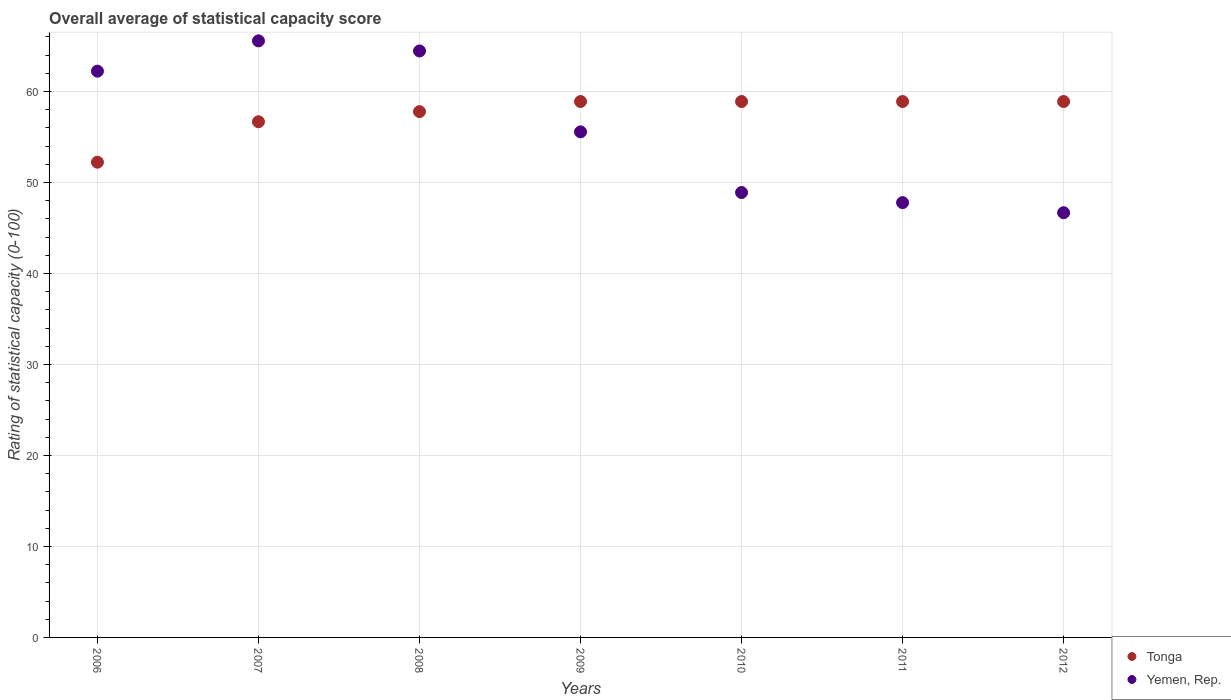Is the number of dotlines equal to the number of legend labels?
Make the answer very short. Yes. What is the rating of statistical capacity in Yemen, Rep. in 2010?
Ensure brevity in your answer.  48.89. Across all years, what is the maximum rating of statistical capacity in Yemen, Rep.?
Your answer should be compact. 65.56. Across all years, what is the minimum rating of statistical capacity in Tonga?
Your answer should be compact. 52.22. In which year was the rating of statistical capacity in Tonga maximum?
Make the answer very short. 2009. In which year was the rating of statistical capacity in Tonga minimum?
Your answer should be compact. 2006. What is the total rating of statistical capacity in Tonga in the graph?
Your answer should be compact. 402.22. What is the difference between the rating of statistical capacity in Tonga in 2006 and that in 2011?
Keep it short and to the point. -6.67. What is the difference between the rating of statistical capacity in Yemen, Rep. in 2007 and the rating of statistical capacity in Tonga in 2008?
Your answer should be compact. 7.78. What is the average rating of statistical capacity in Tonga per year?
Provide a succinct answer. 57.46. In the year 2011, what is the difference between the rating of statistical capacity in Tonga and rating of statistical capacity in Yemen, Rep.?
Make the answer very short. 11.11. In how many years, is the rating of statistical capacity in Yemen, Rep. greater than 24?
Offer a terse response. 7. What is the ratio of the rating of statistical capacity in Yemen, Rep. in 2009 to that in 2011?
Keep it short and to the point. 1.16. Is the rating of statistical capacity in Tonga in 2010 less than that in 2012?
Keep it short and to the point. No. What is the difference between the highest and the second highest rating of statistical capacity in Yemen, Rep.?
Make the answer very short. 1.11. What is the difference between the highest and the lowest rating of statistical capacity in Tonga?
Ensure brevity in your answer.  6.67. In how many years, is the rating of statistical capacity in Yemen, Rep. greater than the average rating of statistical capacity in Yemen, Rep. taken over all years?
Your response must be concise. 3. Is the sum of the rating of statistical capacity in Tonga in 2008 and 2012 greater than the maximum rating of statistical capacity in Yemen, Rep. across all years?
Give a very brief answer. Yes. Does the rating of statistical capacity in Yemen, Rep. monotonically increase over the years?
Make the answer very short. No. How many dotlines are there?
Make the answer very short. 2. Does the graph contain grids?
Offer a terse response. Yes. Where does the legend appear in the graph?
Provide a short and direct response. Bottom right. What is the title of the graph?
Offer a terse response. Overall average of statistical capacity score. Does "Ethiopia" appear as one of the legend labels in the graph?
Your response must be concise. No. What is the label or title of the X-axis?
Keep it short and to the point. Years. What is the label or title of the Y-axis?
Keep it short and to the point. Rating of statistical capacity (0-100). What is the Rating of statistical capacity (0-100) in Tonga in 2006?
Your response must be concise. 52.22. What is the Rating of statistical capacity (0-100) of Yemen, Rep. in 2006?
Offer a terse response. 62.22. What is the Rating of statistical capacity (0-100) of Tonga in 2007?
Provide a short and direct response. 56.67. What is the Rating of statistical capacity (0-100) in Yemen, Rep. in 2007?
Offer a terse response. 65.56. What is the Rating of statistical capacity (0-100) in Tonga in 2008?
Keep it short and to the point. 57.78. What is the Rating of statistical capacity (0-100) in Yemen, Rep. in 2008?
Provide a short and direct response. 64.44. What is the Rating of statistical capacity (0-100) in Tonga in 2009?
Provide a short and direct response. 58.89. What is the Rating of statistical capacity (0-100) in Yemen, Rep. in 2009?
Your answer should be compact. 55.56. What is the Rating of statistical capacity (0-100) in Tonga in 2010?
Offer a terse response. 58.89. What is the Rating of statistical capacity (0-100) of Yemen, Rep. in 2010?
Your answer should be very brief. 48.89. What is the Rating of statistical capacity (0-100) of Tonga in 2011?
Offer a terse response. 58.89. What is the Rating of statistical capacity (0-100) of Yemen, Rep. in 2011?
Offer a terse response. 47.78. What is the Rating of statistical capacity (0-100) of Tonga in 2012?
Give a very brief answer. 58.89. What is the Rating of statistical capacity (0-100) of Yemen, Rep. in 2012?
Your answer should be compact. 46.67. Across all years, what is the maximum Rating of statistical capacity (0-100) in Tonga?
Offer a very short reply. 58.89. Across all years, what is the maximum Rating of statistical capacity (0-100) in Yemen, Rep.?
Provide a succinct answer. 65.56. Across all years, what is the minimum Rating of statistical capacity (0-100) in Tonga?
Ensure brevity in your answer.  52.22. Across all years, what is the minimum Rating of statistical capacity (0-100) of Yemen, Rep.?
Provide a succinct answer. 46.67. What is the total Rating of statistical capacity (0-100) in Tonga in the graph?
Offer a very short reply. 402.22. What is the total Rating of statistical capacity (0-100) of Yemen, Rep. in the graph?
Make the answer very short. 391.11. What is the difference between the Rating of statistical capacity (0-100) of Tonga in 2006 and that in 2007?
Ensure brevity in your answer.  -4.44. What is the difference between the Rating of statistical capacity (0-100) of Yemen, Rep. in 2006 and that in 2007?
Your answer should be compact. -3.33. What is the difference between the Rating of statistical capacity (0-100) of Tonga in 2006 and that in 2008?
Your response must be concise. -5.56. What is the difference between the Rating of statistical capacity (0-100) in Yemen, Rep. in 2006 and that in 2008?
Ensure brevity in your answer.  -2.22. What is the difference between the Rating of statistical capacity (0-100) in Tonga in 2006 and that in 2009?
Offer a very short reply. -6.67. What is the difference between the Rating of statistical capacity (0-100) of Yemen, Rep. in 2006 and that in 2009?
Make the answer very short. 6.67. What is the difference between the Rating of statistical capacity (0-100) in Tonga in 2006 and that in 2010?
Your response must be concise. -6.67. What is the difference between the Rating of statistical capacity (0-100) in Yemen, Rep. in 2006 and that in 2010?
Give a very brief answer. 13.33. What is the difference between the Rating of statistical capacity (0-100) of Tonga in 2006 and that in 2011?
Keep it short and to the point. -6.67. What is the difference between the Rating of statistical capacity (0-100) in Yemen, Rep. in 2006 and that in 2011?
Ensure brevity in your answer.  14.44. What is the difference between the Rating of statistical capacity (0-100) in Tonga in 2006 and that in 2012?
Make the answer very short. -6.67. What is the difference between the Rating of statistical capacity (0-100) in Yemen, Rep. in 2006 and that in 2012?
Offer a terse response. 15.56. What is the difference between the Rating of statistical capacity (0-100) of Tonga in 2007 and that in 2008?
Your response must be concise. -1.11. What is the difference between the Rating of statistical capacity (0-100) in Tonga in 2007 and that in 2009?
Keep it short and to the point. -2.22. What is the difference between the Rating of statistical capacity (0-100) in Yemen, Rep. in 2007 and that in 2009?
Offer a very short reply. 10. What is the difference between the Rating of statistical capacity (0-100) of Tonga in 2007 and that in 2010?
Your answer should be compact. -2.22. What is the difference between the Rating of statistical capacity (0-100) of Yemen, Rep. in 2007 and that in 2010?
Provide a short and direct response. 16.67. What is the difference between the Rating of statistical capacity (0-100) in Tonga in 2007 and that in 2011?
Provide a succinct answer. -2.22. What is the difference between the Rating of statistical capacity (0-100) of Yemen, Rep. in 2007 and that in 2011?
Give a very brief answer. 17.78. What is the difference between the Rating of statistical capacity (0-100) of Tonga in 2007 and that in 2012?
Your answer should be very brief. -2.22. What is the difference between the Rating of statistical capacity (0-100) in Yemen, Rep. in 2007 and that in 2012?
Make the answer very short. 18.89. What is the difference between the Rating of statistical capacity (0-100) in Tonga in 2008 and that in 2009?
Provide a succinct answer. -1.11. What is the difference between the Rating of statistical capacity (0-100) of Yemen, Rep. in 2008 and that in 2009?
Provide a succinct answer. 8.89. What is the difference between the Rating of statistical capacity (0-100) in Tonga in 2008 and that in 2010?
Your answer should be very brief. -1.11. What is the difference between the Rating of statistical capacity (0-100) in Yemen, Rep. in 2008 and that in 2010?
Make the answer very short. 15.56. What is the difference between the Rating of statistical capacity (0-100) in Tonga in 2008 and that in 2011?
Give a very brief answer. -1.11. What is the difference between the Rating of statistical capacity (0-100) of Yemen, Rep. in 2008 and that in 2011?
Offer a very short reply. 16.67. What is the difference between the Rating of statistical capacity (0-100) of Tonga in 2008 and that in 2012?
Offer a very short reply. -1.11. What is the difference between the Rating of statistical capacity (0-100) in Yemen, Rep. in 2008 and that in 2012?
Your answer should be very brief. 17.78. What is the difference between the Rating of statistical capacity (0-100) in Tonga in 2009 and that in 2010?
Provide a short and direct response. 0. What is the difference between the Rating of statistical capacity (0-100) of Yemen, Rep. in 2009 and that in 2010?
Ensure brevity in your answer.  6.67. What is the difference between the Rating of statistical capacity (0-100) in Tonga in 2009 and that in 2011?
Give a very brief answer. 0. What is the difference between the Rating of statistical capacity (0-100) in Yemen, Rep. in 2009 and that in 2011?
Offer a very short reply. 7.78. What is the difference between the Rating of statistical capacity (0-100) in Tonga in 2009 and that in 2012?
Provide a short and direct response. 0. What is the difference between the Rating of statistical capacity (0-100) in Yemen, Rep. in 2009 and that in 2012?
Provide a succinct answer. 8.89. What is the difference between the Rating of statistical capacity (0-100) of Tonga in 2010 and that in 2011?
Your answer should be very brief. 0. What is the difference between the Rating of statistical capacity (0-100) in Yemen, Rep. in 2010 and that in 2011?
Keep it short and to the point. 1.11. What is the difference between the Rating of statistical capacity (0-100) in Tonga in 2010 and that in 2012?
Make the answer very short. 0. What is the difference between the Rating of statistical capacity (0-100) of Yemen, Rep. in 2010 and that in 2012?
Make the answer very short. 2.22. What is the difference between the Rating of statistical capacity (0-100) in Tonga in 2011 and that in 2012?
Provide a succinct answer. 0. What is the difference between the Rating of statistical capacity (0-100) of Tonga in 2006 and the Rating of statistical capacity (0-100) of Yemen, Rep. in 2007?
Ensure brevity in your answer.  -13.33. What is the difference between the Rating of statistical capacity (0-100) in Tonga in 2006 and the Rating of statistical capacity (0-100) in Yemen, Rep. in 2008?
Offer a terse response. -12.22. What is the difference between the Rating of statistical capacity (0-100) in Tonga in 2006 and the Rating of statistical capacity (0-100) in Yemen, Rep. in 2011?
Give a very brief answer. 4.44. What is the difference between the Rating of statistical capacity (0-100) in Tonga in 2006 and the Rating of statistical capacity (0-100) in Yemen, Rep. in 2012?
Offer a very short reply. 5.56. What is the difference between the Rating of statistical capacity (0-100) of Tonga in 2007 and the Rating of statistical capacity (0-100) of Yemen, Rep. in 2008?
Offer a very short reply. -7.78. What is the difference between the Rating of statistical capacity (0-100) of Tonga in 2007 and the Rating of statistical capacity (0-100) of Yemen, Rep. in 2010?
Make the answer very short. 7.78. What is the difference between the Rating of statistical capacity (0-100) in Tonga in 2007 and the Rating of statistical capacity (0-100) in Yemen, Rep. in 2011?
Give a very brief answer. 8.89. What is the difference between the Rating of statistical capacity (0-100) in Tonga in 2007 and the Rating of statistical capacity (0-100) in Yemen, Rep. in 2012?
Ensure brevity in your answer.  10. What is the difference between the Rating of statistical capacity (0-100) in Tonga in 2008 and the Rating of statistical capacity (0-100) in Yemen, Rep. in 2009?
Provide a succinct answer. 2.22. What is the difference between the Rating of statistical capacity (0-100) of Tonga in 2008 and the Rating of statistical capacity (0-100) of Yemen, Rep. in 2010?
Offer a terse response. 8.89. What is the difference between the Rating of statistical capacity (0-100) in Tonga in 2008 and the Rating of statistical capacity (0-100) in Yemen, Rep. in 2012?
Provide a succinct answer. 11.11. What is the difference between the Rating of statistical capacity (0-100) of Tonga in 2009 and the Rating of statistical capacity (0-100) of Yemen, Rep. in 2011?
Your answer should be very brief. 11.11. What is the difference between the Rating of statistical capacity (0-100) in Tonga in 2009 and the Rating of statistical capacity (0-100) in Yemen, Rep. in 2012?
Provide a succinct answer. 12.22. What is the difference between the Rating of statistical capacity (0-100) of Tonga in 2010 and the Rating of statistical capacity (0-100) of Yemen, Rep. in 2011?
Your answer should be very brief. 11.11. What is the difference between the Rating of statistical capacity (0-100) of Tonga in 2010 and the Rating of statistical capacity (0-100) of Yemen, Rep. in 2012?
Your answer should be very brief. 12.22. What is the difference between the Rating of statistical capacity (0-100) in Tonga in 2011 and the Rating of statistical capacity (0-100) in Yemen, Rep. in 2012?
Provide a succinct answer. 12.22. What is the average Rating of statistical capacity (0-100) of Tonga per year?
Keep it short and to the point. 57.46. What is the average Rating of statistical capacity (0-100) in Yemen, Rep. per year?
Give a very brief answer. 55.87. In the year 2007, what is the difference between the Rating of statistical capacity (0-100) of Tonga and Rating of statistical capacity (0-100) of Yemen, Rep.?
Your response must be concise. -8.89. In the year 2008, what is the difference between the Rating of statistical capacity (0-100) in Tonga and Rating of statistical capacity (0-100) in Yemen, Rep.?
Keep it short and to the point. -6.67. In the year 2009, what is the difference between the Rating of statistical capacity (0-100) of Tonga and Rating of statistical capacity (0-100) of Yemen, Rep.?
Your answer should be very brief. 3.33. In the year 2010, what is the difference between the Rating of statistical capacity (0-100) of Tonga and Rating of statistical capacity (0-100) of Yemen, Rep.?
Your answer should be compact. 10. In the year 2011, what is the difference between the Rating of statistical capacity (0-100) in Tonga and Rating of statistical capacity (0-100) in Yemen, Rep.?
Ensure brevity in your answer.  11.11. In the year 2012, what is the difference between the Rating of statistical capacity (0-100) of Tonga and Rating of statistical capacity (0-100) of Yemen, Rep.?
Give a very brief answer. 12.22. What is the ratio of the Rating of statistical capacity (0-100) in Tonga in 2006 to that in 2007?
Your answer should be very brief. 0.92. What is the ratio of the Rating of statistical capacity (0-100) in Yemen, Rep. in 2006 to that in 2007?
Keep it short and to the point. 0.95. What is the ratio of the Rating of statistical capacity (0-100) of Tonga in 2006 to that in 2008?
Make the answer very short. 0.9. What is the ratio of the Rating of statistical capacity (0-100) in Yemen, Rep. in 2006 to that in 2008?
Your response must be concise. 0.97. What is the ratio of the Rating of statistical capacity (0-100) in Tonga in 2006 to that in 2009?
Offer a very short reply. 0.89. What is the ratio of the Rating of statistical capacity (0-100) in Yemen, Rep. in 2006 to that in 2009?
Provide a succinct answer. 1.12. What is the ratio of the Rating of statistical capacity (0-100) in Tonga in 2006 to that in 2010?
Provide a short and direct response. 0.89. What is the ratio of the Rating of statistical capacity (0-100) of Yemen, Rep. in 2006 to that in 2010?
Your response must be concise. 1.27. What is the ratio of the Rating of statistical capacity (0-100) in Tonga in 2006 to that in 2011?
Ensure brevity in your answer.  0.89. What is the ratio of the Rating of statistical capacity (0-100) of Yemen, Rep. in 2006 to that in 2011?
Make the answer very short. 1.3. What is the ratio of the Rating of statistical capacity (0-100) of Tonga in 2006 to that in 2012?
Offer a very short reply. 0.89. What is the ratio of the Rating of statistical capacity (0-100) of Tonga in 2007 to that in 2008?
Ensure brevity in your answer.  0.98. What is the ratio of the Rating of statistical capacity (0-100) of Yemen, Rep. in 2007 to that in 2008?
Ensure brevity in your answer.  1.02. What is the ratio of the Rating of statistical capacity (0-100) of Tonga in 2007 to that in 2009?
Make the answer very short. 0.96. What is the ratio of the Rating of statistical capacity (0-100) of Yemen, Rep. in 2007 to that in 2009?
Your answer should be very brief. 1.18. What is the ratio of the Rating of statistical capacity (0-100) in Tonga in 2007 to that in 2010?
Ensure brevity in your answer.  0.96. What is the ratio of the Rating of statistical capacity (0-100) in Yemen, Rep. in 2007 to that in 2010?
Ensure brevity in your answer.  1.34. What is the ratio of the Rating of statistical capacity (0-100) of Tonga in 2007 to that in 2011?
Offer a very short reply. 0.96. What is the ratio of the Rating of statistical capacity (0-100) of Yemen, Rep. in 2007 to that in 2011?
Your response must be concise. 1.37. What is the ratio of the Rating of statistical capacity (0-100) of Tonga in 2007 to that in 2012?
Your answer should be compact. 0.96. What is the ratio of the Rating of statistical capacity (0-100) of Yemen, Rep. in 2007 to that in 2012?
Offer a very short reply. 1.4. What is the ratio of the Rating of statistical capacity (0-100) of Tonga in 2008 to that in 2009?
Keep it short and to the point. 0.98. What is the ratio of the Rating of statistical capacity (0-100) of Yemen, Rep. in 2008 to that in 2009?
Your response must be concise. 1.16. What is the ratio of the Rating of statistical capacity (0-100) in Tonga in 2008 to that in 2010?
Offer a very short reply. 0.98. What is the ratio of the Rating of statistical capacity (0-100) of Yemen, Rep. in 2008 to that in 2010?
Make the answer very short. 1.32. What is the ratio of the Rating of statistical capacity (0-100) in Tonga in 2008 to that in 2011?
Provide a succinct answer. 0.98. What is the ratio of the Rating of statistical capacity (0-100) in Yemen, Rep. in 2008 to that in 2011?
Your answer should be very brief. 1.35. What is the ratio of the Rating of statistical capacity (0-100) in Tonga in 2008 to that in 2012?
Your answer should be compact. 0.98. What is the ratio of the Rating of statistical capacity (0-100) in Yemen, Rep. in 2008 to that in 2012?
Your answer should be very brief. 1.38. What is the ratio of the Rating of statistical capacity (0-100) of Yemen, Rep. in 2009 to that in 2010?
Your answer should be compact. 1.14. What is the ratio of the Rating of statistical capacity (0-100) in Tonga in 2009 to that in 2011?
Your answer should be compact. 1. What is the ratio of the Rating of statistical capacity (0-100) in Yemen, Rep. in 2009 to that in 2011?
Keep it short and to the point. 1.16. What is the ratio of the Rating of statistical capacity (0-100) in Tonga in 2009 to that in 2012?
Provide a succinct answer. 1. What is the ratio of the Rating of statistical capacity (0-100) of Yemen, Rep. in 2009 to that in 2012?
Offer a terse response. 1.19. What is the ratio of the Rating of statistical capacity (0-100) in Yemen, Rep. in 2010 to that in 2011?
Give a very brief answer. 1.02. What is the ratio of the Rating of statistical capacity (0-100) of Tonga in 2010 to that in 2012?
Provide a short and direct response. 1. What is the ratio of the Rating of statistical capacity (0-100) in Yemen, Rep. in 2010 to that in 2012?
Your response must be concise. 1.05. What is the ratio of the Rating of statistical capacity (0-100) in Tonga in 2011 to that in 2012?
Provide a succinct answer. 1. What is the ratio of the Rating of statistical capacity (0-100) in Yemen, Rep. in 2011 to that in 2012?
Your answer should be compact. 1.02. What is the difference between the highest and the second highest Rating of statistical capacity (0-100) of Tonga?
Offer a very short reply. 0. What is the difference between the highest and the lowest Rating of statistical capacity (0-100) of Yemen, Rep.?
Your answer should be very brief. 18.89. 